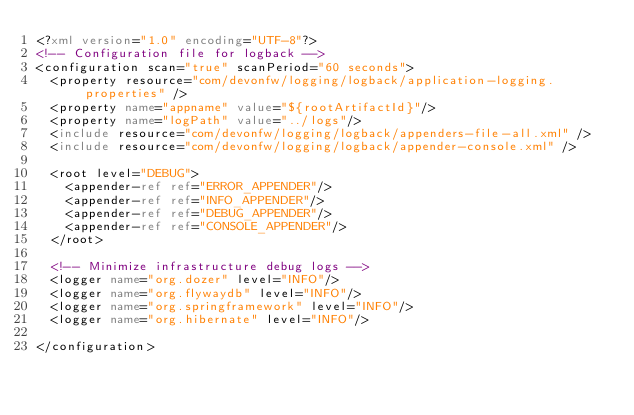Convert code to text. <code><loc_0><loc_0><loc_500><loc_500><_XML_><?xml version="1.0" encoding="UTF-8"?>
<!-- Configuration file for logback -->
<configuration scan="true" scanPeriod="60 seconds">
  <property resource="com/devonfw/logging/logback/application-logging.properties" />
  <property name="appname" value="${rootArtifactId}"/>
  <property name="logPath" value="../logs"/>
  <include resource="com/devonfw/logging/logback/appenders-file-all.xml" />
  <include resource="com/devonfw/logging/logback/appender-console.xml" />

  <root level="DEBUG">
    <appender-ref ref="ERROR_APPENDER"/>
    <appender-ref ref="INFO_APPENDER"/>
    <appender-ref ref="DEBUG_APPENDER"/>
    <appender-ref ref="CONSOLE_APPENDER"/>
  </root>

  <!-- Minimize infrastructure debug logs -->
  <logger name="org.dozer" level="INFO"/>
  <logger name="org.flywaydb" level="INFO"/>
  <logger name="org.springframework" level="INFO"/>
  <logger name="org.hibernate" level="INFO"/>

</configuration>
</code> 